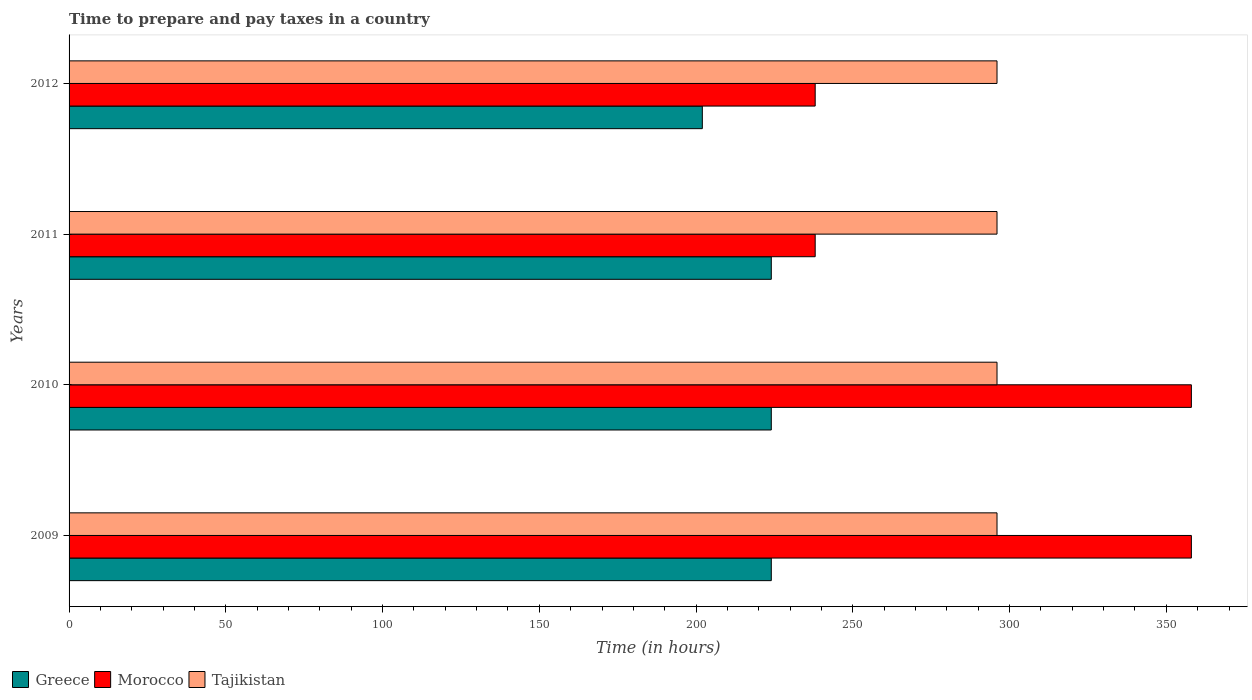Are the number of bars per tick equal to the number of legend labels?
Your answer should be very brief. Yes. What is the number of hours required to prepare and pay taxes in Tajikistan in 2010?
Keep it short and to the point. 296. Across all years, what is the maximum number of hours required to prepare and pay taxes in Morocco?
Your response must be concise. 358. Across all years, what is the minimum number of hours required to prepare and pay taxes in Morocco?
Offer a very short reply. 238. In which year was the number of hours required to prepare and pay taxes in Morocco maximum?
Your answer should be very brief. 2009. What is the total number of hours required to prepare and pay taxes in Morocco in the graph?
Ensure brevity in your answer.  1192. What is the difference between the number of hours required to prepare and pay taxes in Morocco in 2009 and that in 2011?
Your response must be concise. 120. What is the difference between the number of hours required to prepare and pay taxes in Greece in 2010 and the number of hours required to prepare and pay taxes in Morocco in 2012?
Give a very brief answer. -14. What is the average number of hours required to prepare and pay taxes in Morocco per year?
Provide a short and direct response. 298. In the year 2010, what is the difference between the number of hours required to prepare and pay taxes in Greece and number of hours required to prepare and pay taxes in Morocco?
Provide a short and direct response. -134. What is the ratio of the number of hours required to prepare and pay taxes in Morocco in 2010 to that in 2011?
Provide a short and direct response. 1.5. Is the number of hours required to prepare and pay taxes in Greece in 2009 less than that in 2012?
Your answer should be compact. No. What is the difference between the highest and the second highest number of hours required to prepare and pay taxes in Greece?
Your answer should be very brief. 0. What is the difference between the highest and the lowest number of hours required to prepare and pay taxes in Greece?
Provide a short and direct response. 22. In how many years, is the number of hours required to prepare and pay taxes in Morocco greater than the average number of hours required to prepare and pay taxes in Morocco taken over all years?
Provide a short and direct response. 2. What does the 2nd bar from the top in 2012 represents?
Your answer should be very brief. Morocco. What does the 2nd bar from the bottom in 2012 represents?
Offer a very short reply. Morocco. Is it the case that in every year, the sum of the number of hours required to prepare and pay taxes in Greece and number of hours required to prepare and pay taxes in Tajikistan is greater than the number of hours required to prepare and pay taxes in Morocco?
Offer a terse response. Yes. How many years are there in the graph?
Offer a very short reply. 4. What is the difference between two consecutive major ticks on the X-axis?
Offer a terse response. 50. Does the graph contain any zero values?
Your answer should be compact. No. Where does the legend appear in the graph?
Ensure brevity in your answer.  Bottom left. How are the legend labels stacked?
Provide a succinct answer. Horizontal. What is the title of the graph?
Provide a succinct answer. Time to prepare and pay taxes in a country. What is the label or title of the X-axis?
Offer a terse response. Time (in hours). What is the Time (in hours) in Greece in 2009?
Your answer should be compact. 224. What is the Time (in hours) in Morocco in 2009?
Your response must be concise. 358. What is the Time (in hours) in Tajikistan in 2009?
Your answer should be very brief. 296. What is the Time (in hours) of Greece in 2010?
Keep it short and to the point. 224. What is the Time (in hours) of Morocco in 2010?
Ensure brevity in your answer.  358. What is the Time (in hours) of Tajikistan in 2010?
Make the answer very short. 296. What is the Time (in hours) in Greece in 2011?
Ensure brevity in your answer.  224. What is the Time (in hours) in Morocco in 2011?
Make the answer very short. 238. What is the Time (in hours) in Tajikistan in 2011?
Ensure brevity in your answer.  296. What is the Time (in hours) in Greece in 2012?
Your answer should be compact. 202. What is the Time (in hours) in Morocco in 2012?
Offer a terse response. 238. What is the Time (in hours) in Tajikistan in 2012?
Your answer should be very brief. 296. Across all years, what is the maximum Time (in hours) in Greece?
Provide a succinct answer. 224. Across all years, what is the maximum Time (in hours) of Morocco?
Offer a terse response. 358. Across all years, what is the maximum Time (in hours) in Tajikistan?
Provide a short and direct response. 296. Across all years, what is the minimum Time (in hours) of Greece?
Make the answer very short. 202. Across all years, what is the minimum Time (in hours) in Morocco?
Provide a short and direct response. 238. Across all years, what is the minimum Time (in hours) in Tajikistan?
Provide a succinct answer. 296. What is the total Time (in hours) of Greece in the graph?
Offer a very short reply. 874. What is the total Time (in hours) of Morocco in the graph?
Offer a very short reply. 1192. What is the total Time (in hours) of Tajikistan in the graph?
Your answer should be compact. 1184. What is the difference between the Time (in hours) of Greece in 2009 and that in 2010?
Your response must be concise. 0. What is the difference between the Time (in hours) of Morocco in 2009 and that in 2010?
Your answer should be very brief. 0. What is the difference between the Time (in hours) of Tajikistan in 2009 and that in 2010?
Keep it short and to the point. 0. What is the difference between the Time (in hours) in Greece in 2009 and that in 2011?
Provide a short and direct response. 0. What is the difference between the Time (in hours) in Morocco in 2009 and that in 2011?
Your response must be concise. 120. What is the difference between the Time (in hours) of Morocco in 2009 and that in 2012?
Your response must be concise. 120. What is the difference between the Time (in hours) in Morocco in 2010 and that in 2011?
Make the answer very short. 120. What is the difference between the Time (in hours) of Greece in 2010 and that in 2012?
Keep it short and to the point. 22. What is the difference between the Time (in hours) of Morocco in 2010 and that in 2012?
Your answer should be very brief. 120. What is the difference between the Time (in hours) of Morocco in 2011 and that in 2012?
Your answer should be very brief. 0. What is the difference between the Time (in hours) in Tajikistan in 2011 and that in 2012?
Offer a terse response. 0. What is the difference between the Time (in hours) of Greece in 2009 and the Time (in hours) of Morocco in 2010?
Provide a short and direct response. -134. What is the difference between the Time (in hours) of Greece in 2009 and the Time (in hours) of Tajikistan in 2010?
Give a very brief answer. -72. What is the difference between the Time (in hours) of Greece in 2009 and the Time (in hours) of Morocco in 2011?
Provide a short and direct response. -14. What is the difference between the Time (in hours) in Greece in 2009 and the Time (in hours) in Tajikistan in 2011?
Provide a short and direct response. -72. What is the difference between the Time (in hours) of Greece in 2009 and the Time (in hours) of Tajikistan in 2012?
Give a very brief answer. -72. What is the difference between the Time (in hours) in Morocco in 2009 and the Time (in hours) in Tajikistan in 2012?
Your answer should be very brief. 62. What is the difference between the Time (in hours) in Greece in 2010 and the Time (in hours) in Tajikistan in 2011?
Make the answer very short. -72. What is the difference between the Time (in hours) in Greece in 2010 and the Time (in hours) in Tajikistan in 2012?
Your answer should be compact. -72. What is the difference between the Time (in hours) of Greece in 2011 and the Time (in hours) of Morocco in 2012?
Provide a succinct answer. -14. What is the difference between the Time (in hours) in Greece in 2011 and the Time (in hours) in Tajikistan in 2012?
Your answer should be very brief. -72. What is the difference between the Time (in hours) in Morocco in 2011 and the Time (in hours) in Tajikistan in 2012?
Give a very brief answer. -58. What is the average Time (in hours) of Greece per year?
Ensure brevity in your answer.  218.5. What is the average Time (in hours) of Morocco per year?
Provide a succinct answer. 298. What is the average Time (in hours) in Tajikistan per year?
Your answer should be very brief. 296. In the year 2009, what is the difference between the Time (in hours) in Greece and Time (in hours) in Morocco?
Keep it short and to the point. -134. In the year 2009, what is the difference between the Time (in hours) in Greece and Time (in hours) in Tajikistan?
Your answer should be very brief. -72. In the year 2010, what is the difference between the Time (in hours) of Greece and Time (in hours) of Morocco?
Provide a succinct answer. -134. In the year 2010, what is the difference between the Time (in hours) of Greece and Time (in hours) of Tajikistan?
Provide a succinct answer. -72. In the year 2011, what is the difference between the Time (in hours) of Greece and Time (in hours) of Morocco?
Provide a short and direct response. -14. In the year 2011, what is the difference between the Time (in hours) in Greece and Time (in hours) in Tajikistan?
Provide a short and direct response. -72. In the year 2011, what is the difference between the Time (in hours) of Morocco and Time (in hours) of Tajikistan?
Provide a succinct answer. -58. In the year 2012, what is the difference between the Time (in hours) in Greece and Time (in hours) in Morocco?
Offer a terse response. -36. In the year 2012, what is the difference between the Time (in hours) in Greece and Time (in hours) in Tajikistan?
Offer a terse response. -94. In the year 2012, what is the difference between the Time (in hours) in Morocco and Time (in hours) in Tajikistan?
Your response must be concise. -58. What is the ratio of the Time (in hours) in Morocco in 2009 to that in 2010?
Make the answer very short. 1. What is the ratio of the Time (in hours) of Tajikistan in 2009 to that in 2010?
Your response must be concise. 1. What is the ratio of the Time (in hours) in Greece in 2009 to that in 2011?
Ensure brevity in your answer.  1. What is the ratio of the Time (in hours) in Morocco in 2009 to that in 2011?
Provide a short and direct response. 1.5. What is the ratio of the Time (in hours) in Greece in 2009 to that in 2012?
Make the answer very short. 1.11. What is the ratio of the Time (in hours) of Morocco in 2009 to that in 2012?
Your answer should be compact. 1.5. What is the ratio of the Time (in hours) of Tajikistan in 2009 to that in 2012?
Your response must be concise. 1. What is the ratio of the Time (in hours) of Morocco in 2010 to that in 2011?
Offer a terse response. 1.5. What is the ratio of the Time (in hours) of Greece in 2010 to that in 2012?
Provide a succinct answer. 1.11. What is the ratio of the Time (in hours) in Morocco in 2010 to that in 2012?
Offer a very short reply. 1.5. What is the ratio of the Time (in hours) of Tajikistan in 2010 to that in 2012?
Offer a terse response. 1. What is the ratio of the Time (in hours) in Greece in 2011 to that in 2012?
Provide a short and direct response. 1.11. What is the ratio of the Time (in hours) in Tajikistan in 2011 to that in 2012?
Give a very brief answer. 1. What is the difference between the highest and the second highest Time (in hours) in Greece?
Keep it short and to the point. 0. What is the difference between the highest and the second highest Time (in hours) in Morocco?
Make the answer very short. 0. What is the difference between the highest and the lowest Time (in hours) of Morocco?
Give a very brief answer. 120. What is the difference between the highest and the lowest Time (in hours) of Tajikistan?
Provide a succinct answer. 0. 